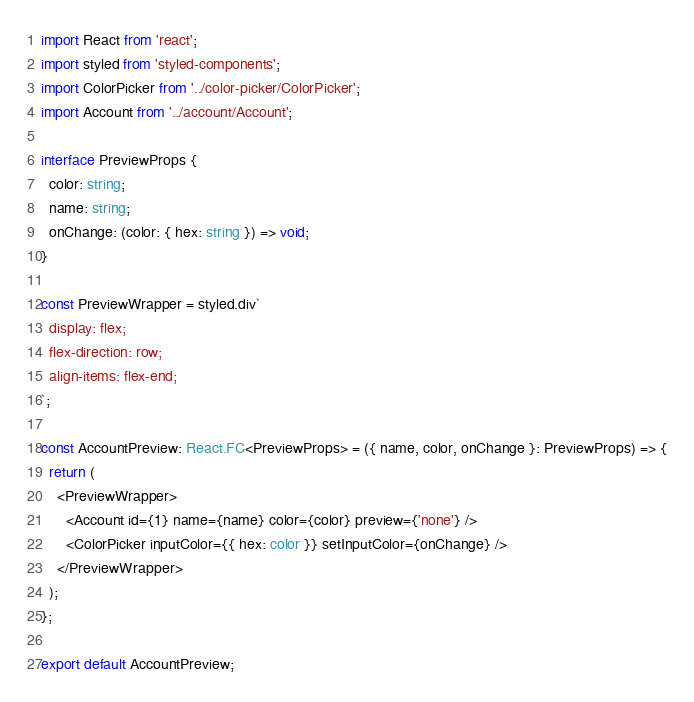<code> <loc_0><loc_0><loc_500><loc_500><_TypeScript_>import React from 'react';
import styled from 'styled-components';
import ColorPicker from '../color-picker/ColorPicker';
import Account from '../account/Account';

interface PreviewProps {
  color: string;
  name: string;
  onChange: (color: { hex: string }) => void;
}

const PreviewWrapper = styled.div`
  display: flex;
  flex-direction: row;
  align-items: flex-end;
`;

const AccountPreview: React.FC<PreviewProps> = ({ name, color, onChange }: PreviewProps) => {
  return (
    <PreviewWrapper>
      <Account id={1} name={name} color={color} preview={'none'} />
      <ColorPicker inputColor={{ hex: color }} setInputColor={onChange} />
    </PreviewWrapper>
  );
};

export default AccountPreview;
</code> 